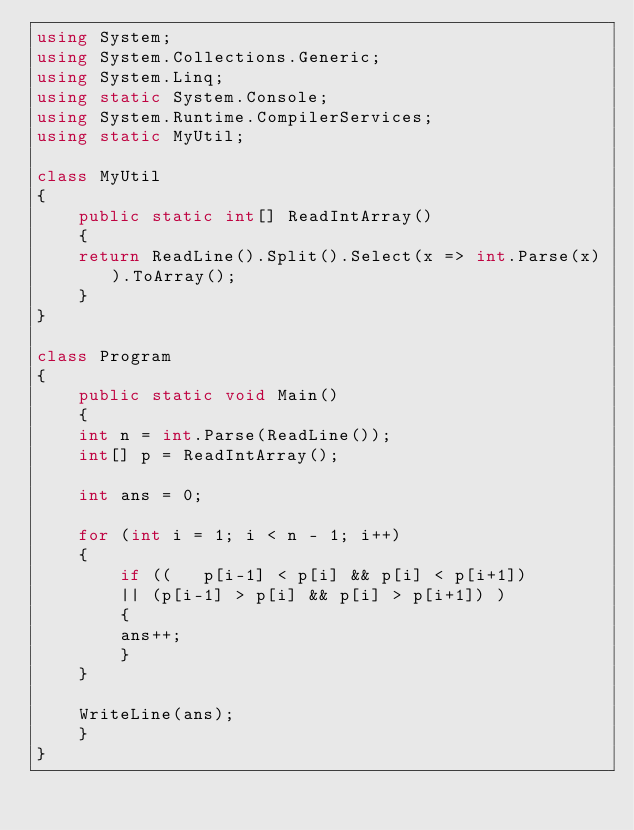Convert code to text. <code><loc_0><loc_0><loc_500><loc_500><_C#_>using System;
using System.Collections.Generic;
using System.Linq;
using static System.Console;
using System.Runtime.CompilerServices;
using static MyUtil;

class MyUtil
{
    public static int[] ReadIntArray()
    {
	return ReadLine().Split().Select(x => int.Parse(x)).ToArray();
    }
}

class Program
{
    public static void Main()
    {
	int n = int.Parse(ReadLine());
	int[] p = ReadIntArray();

	int ans = 0;

	for (int i = 1; i < n - 1; i++)
	{
	    if ((   p[i-1] < p[i] && p[i] < p[i+1])
		|| (p[i-1] > p[i] && p[i] > p[i+1]) )
	    {
		ans++;
	    }
	}

	WriteLine(ans);
    }
}
</code> 